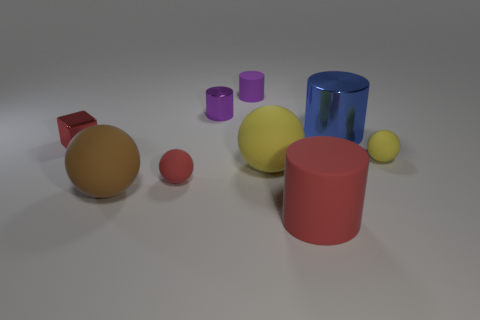What material is the big blue object?
Provide a succinct answer. Metal. There is a yellow thing that is to the left of the large blue metallic thing; how big is it?
Offer a terse response. Large. Is there anything else that is the same color as the block?
Your response must be concise. Yes. There is a tiny ball on the left side of the small metallic thing that is behind the red metal cube; are there any yellow rubber objects on the left side of it?
Ensure brevity in your answer.  No. Does the matte thing that is behind the tiny yellow thing have the same color as the metal cube?
Make the answer very short. No. How many balls are blue things or small matte objects?
Ensure brevity in your answer.  2. The rubber object behind the large cylinder behind the metallic block is what shape?
Provide a short and direct response. Cylinder. There is a rubber thing that is behind the small rubber sphere that is right of the small purple cylinder that is right of the purple metallic object; how big is it?
Keep it short and to the point. Small. Do the red block and the red cylinder have the same size?
Offer a very short reply. No. How many objects are either matte cylinders or big yellow metallic cylinders?
Ensure brevity in your answer.  2. 